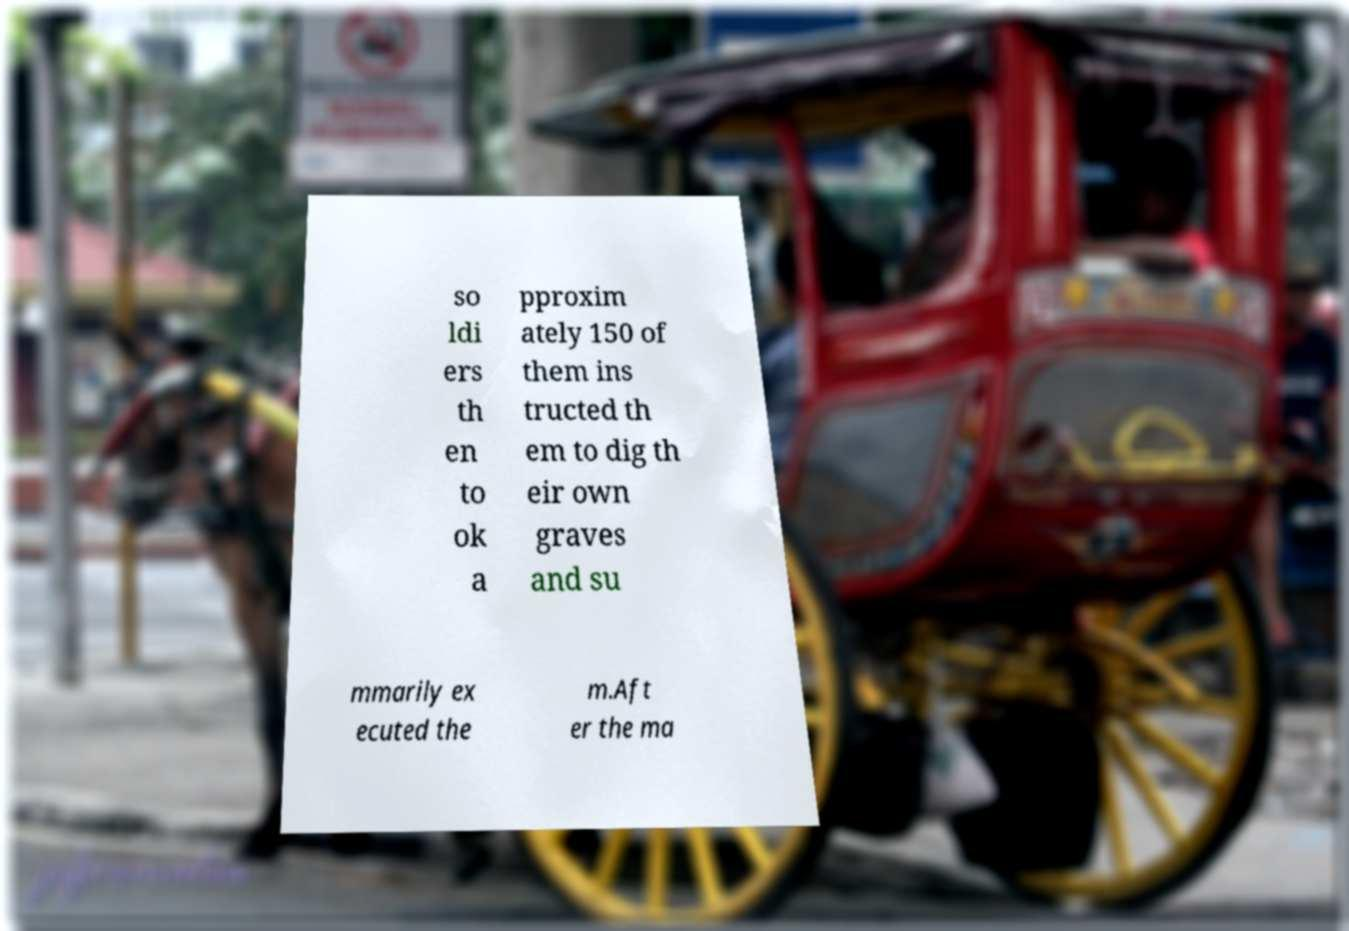Can you read and provide the text displayed in the image?This photo seems to have some interesting text. Can you extract and type it out for me? so ldi ers th en to ok a pproxim ately 150 of them ins tructed th em to dig th eir own graves and su mmarily ex ecuted the m.Aft er the ma 